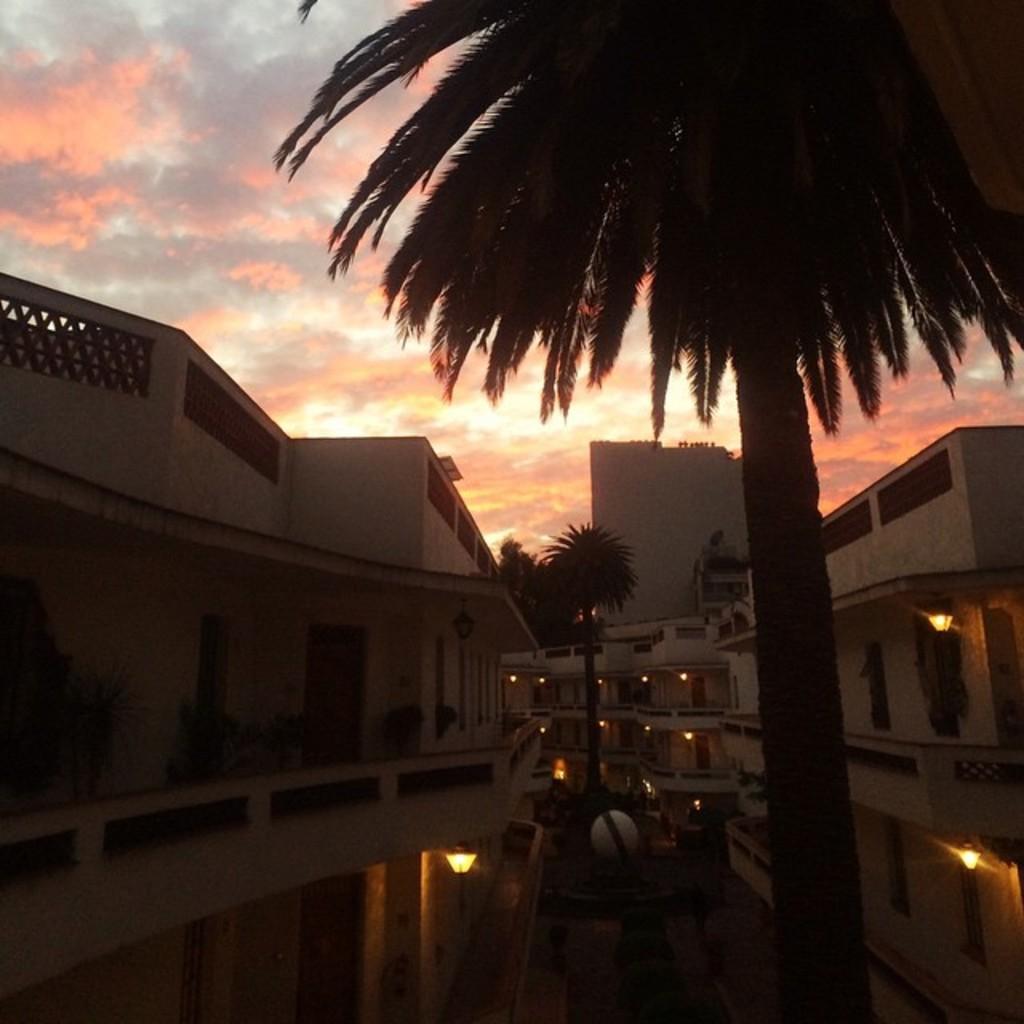Please provide a concise description of this image. In this image there are some trees in middle of this image and there are some buildings in the background and there is a sky at top of this image. 